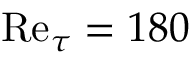<formula> <loc_0><loc_0><loc_500><loc_500>R e _ { \tau } = 1 8 0</formula> 